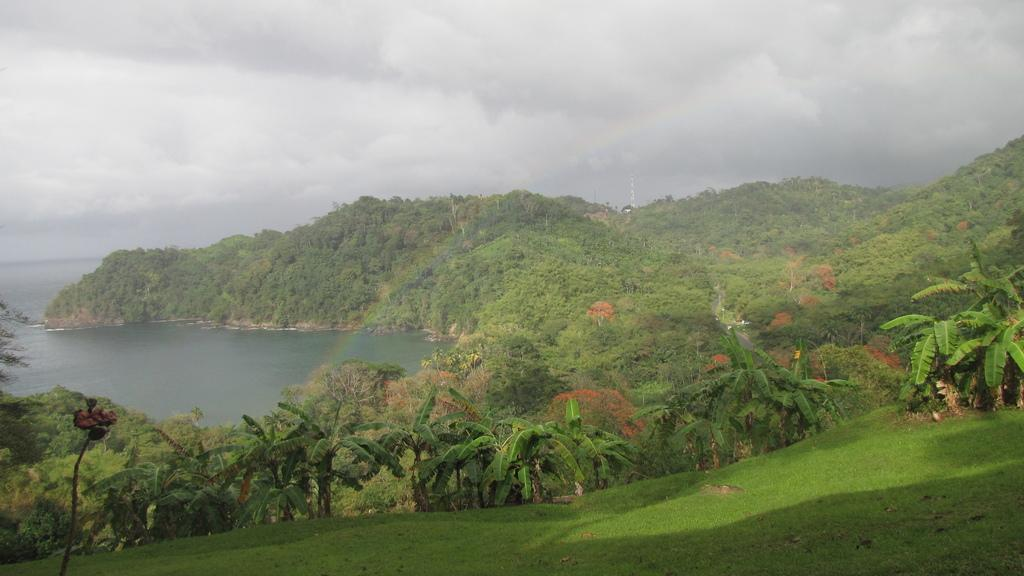What type of vegetation is visible in the image? There is grass in the image. What other natural elements can be seen in the image? There are trees and water visible in the image. What is visible at the top of the image? The sky is visible at the top of the image. What can be observed in the sky? There are clouds visible in the sky. What type of linen is being used to cover the wound in the image? There is no linen or wound present in the image. How does the person in the image appear to be resting? There is no person visible in the image, so it cannot be determined if anyone is resting. 